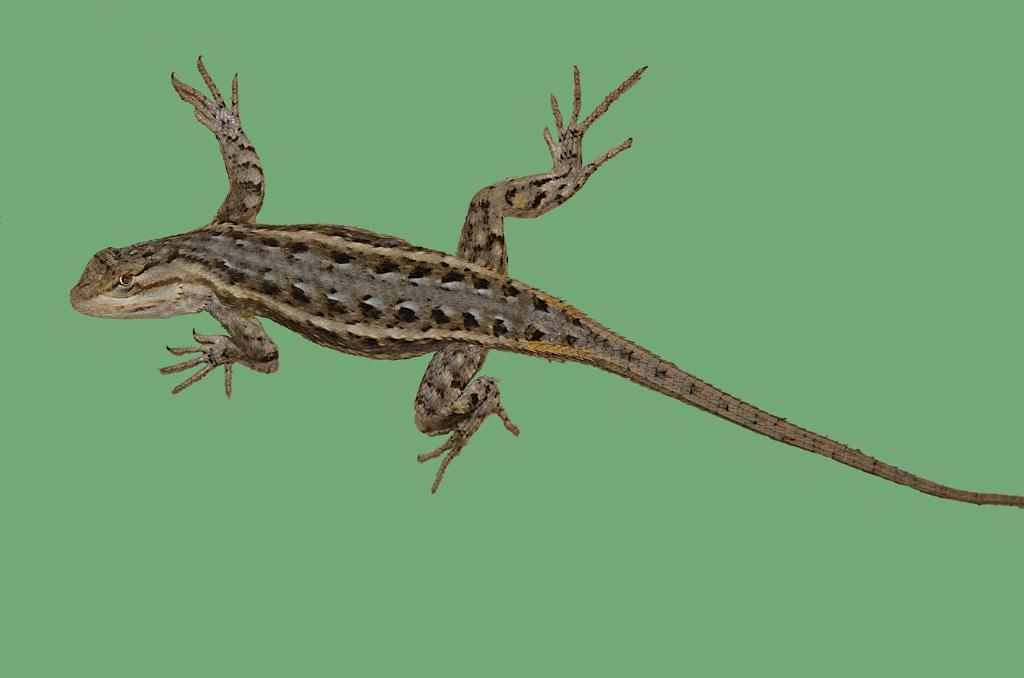What type of animal is in the picture? There is a lizard in the picture. How many legs does the lizard have? The lizard has four legs. What other feature can be observed about the lizard? The lizard has a long tail. What type of camera is the lizard using to take pictures in the image? There is no camera present in the image, and the lizard is not taking pictures. 